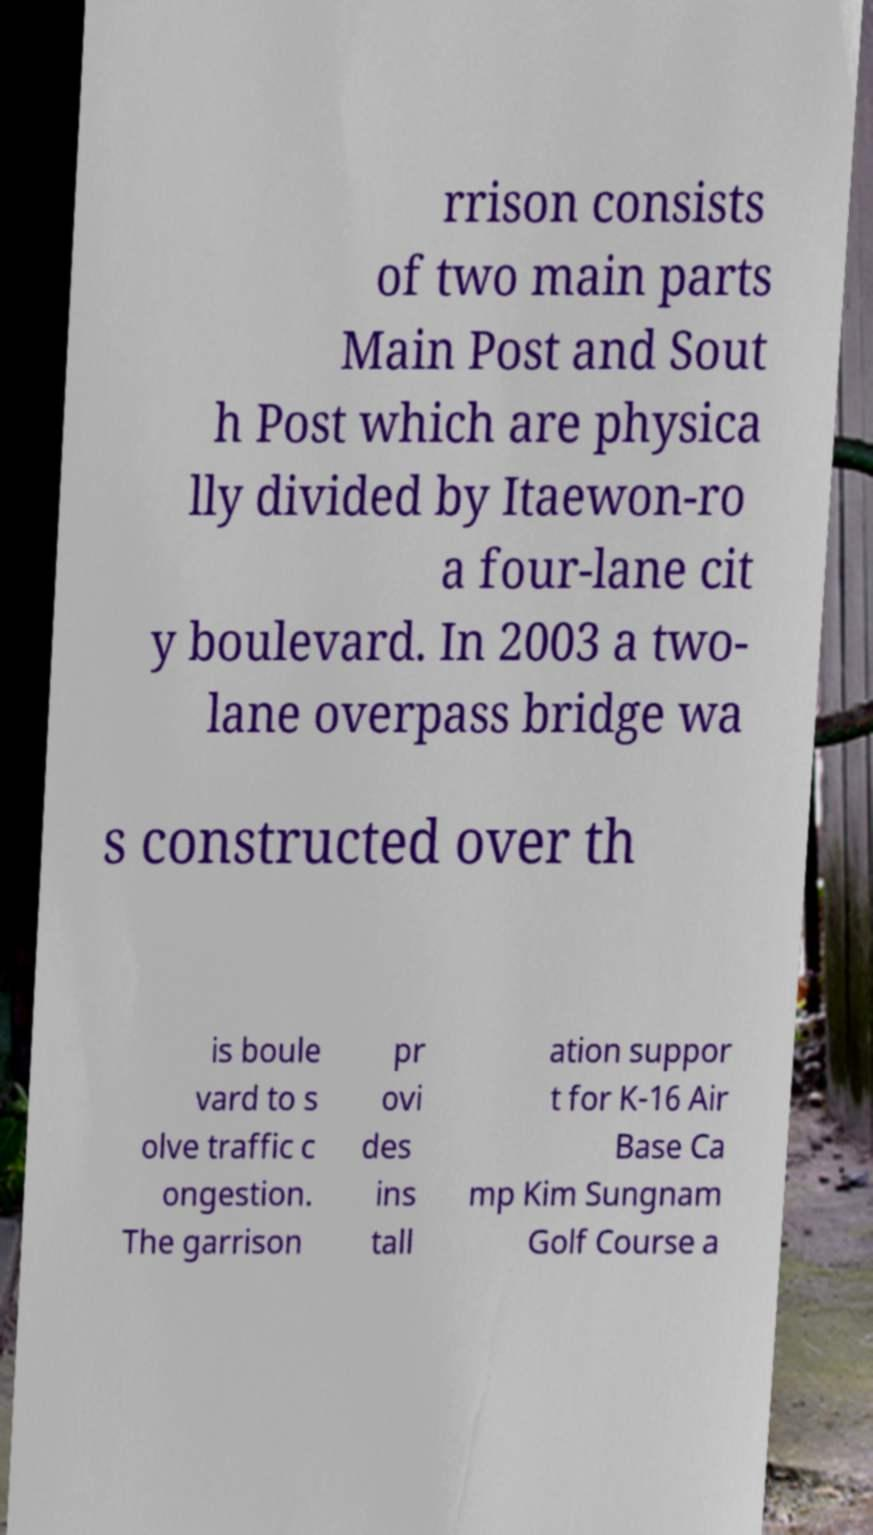What messages or text are displayed in this image? I need them in a readable, typed format. rrison consists of two main parts Main Post and Sout h Post which are physica lly divided by Itaewon-ro a four-lane cit y boulevard. In 2003 a two- lane overpass bridge wa s constructed over th is boule vard to s olve traffic c ongestion. The garrison pr ovi des ins tall ation suppor t for K-16 Air Base Ca mp Kim Sungnam Golf Course a 